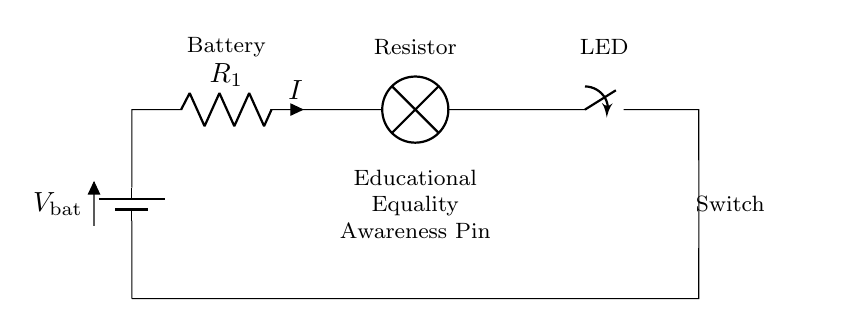What are the components used in this circuit? The circuit contains a battery, resistor, LED, and switch as indicated by the labels on each component.
Answer: Battery, Resistor, LED, Switch What is the purpose of the resistor in this circuit? The resistor limits the current flowing through the circuit to protect the LED from receiving excessive current, which could damage it.
Answer: Current limiting What is the direction of current flow when the switch is closed? When the switch is closed, the current flows from the positive terminal of the battery, through the resistor, then through the LED, and back to the negative terminal of the battery.
Answer: Clockwise How many components are in series in this circuit? All components (battery, resistor, LED, and switch) are connected end-to-end, making a total of four components in series.
Answer: Four What happens to the LED when the switch is open? When the switch is open, the circuit becomes incomplete, and no current flows, causing the LED to turn off.
Answer: Turns off How does the series arrangement affect the overall resistance? In a series circuit, the total resistance is the sum of all individual resistances, which increases the total resistance as more components are added.
Answer: Increases total resistance 